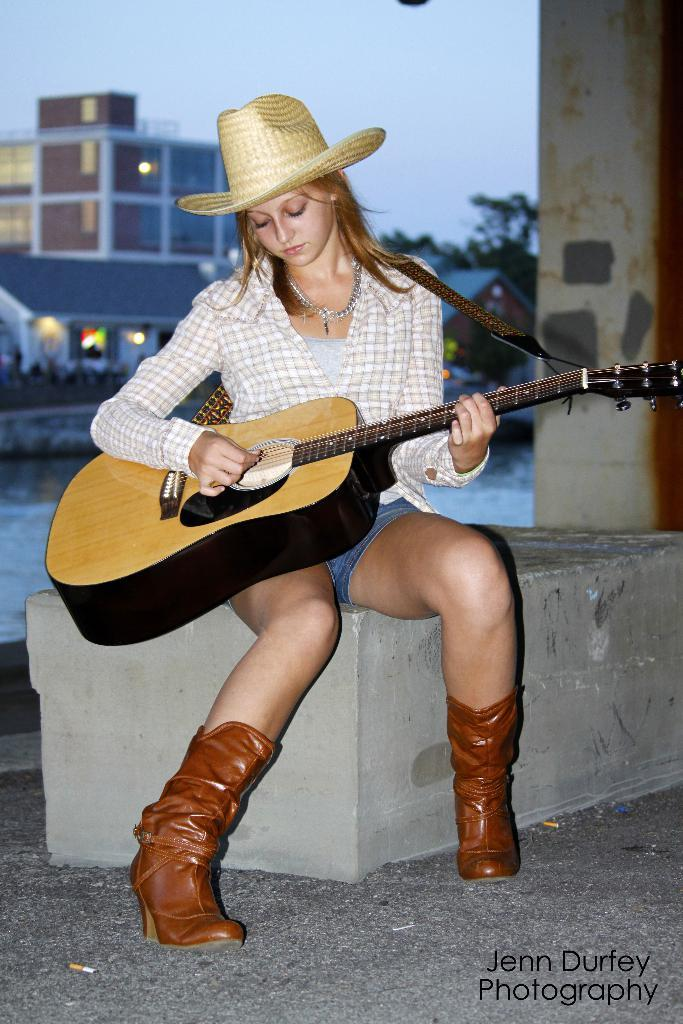What is the person in the image doing? The person is sitting and playing a guitar. What type of clothing is the person wearing? The person is wearing clothes, boots, and a hat. What can be seen in the background of the image? There is a building in the background of the image. What type of skirt is the person wearing in the image? The person is not wearing a skirt in the image; they are wearing clothes, boots, and a hat. Can you see any plantation in the background of the image? There is no plantation visible in the background of the image; only a building can be seen. 